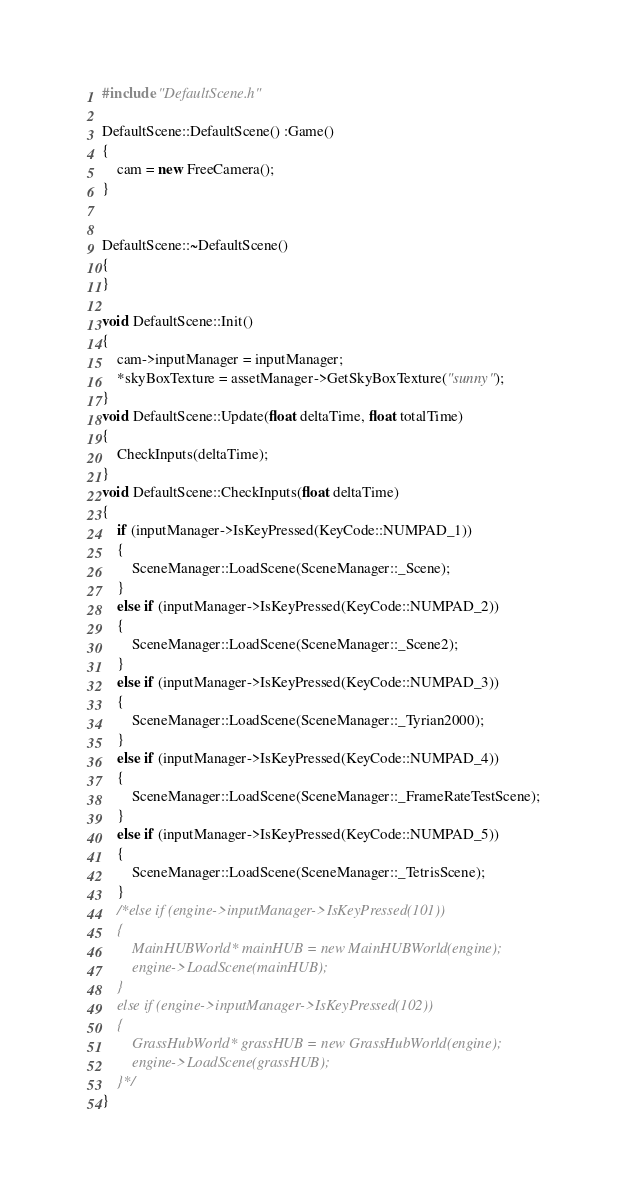Convert code to text. <code><loc_0><loc_0><loc_500><loc_500><_C++_>#include "DefaultScene.h"

DefaultScene::DefaultScene() :Game()
{
	cam = new FreeCamera();
}


DefaultScene::~DefaultScene()
{
}

void DefaultScene::Init()
{
	cam->inputManager = inputManager;
	*skyBoxTexture = assetManager->GetSkyBoxTexture("sunny");
}
void DefaultScene::Update(float deltaTime, float totalTime)
{
	CheckInputs(deltaTime);
}
void DefaultScene::CheckInputs(float deltaTime)
{
	if (inputManager->IsKeyPressed(KeyCode::NUMPAD_1))
	{
		SceneManager::LoadScene(SceneManager::_Scene);
	}
	else if (inputManager->IsKeyPressed(KeyCode::NUMPAD_2))
	{
		SceneManager::LoadScene(SceneManager::_Scene2);
	}
	else if (inputManager->IsKeyPressed(KeyCode::NUMPAD_3))
	{
		SceneManager::LoadScene(SceneManager::_Tyrian2000);
	}
	else if (inputManager->IsKeyPressed(KeyCode::NUMPAD_4))
	{
		SceneManager::LoadScene(SceneManager::_FrameRateTestScene);
	}
	else if (inputManager->IsKeyPressed(KeyCode::NUMPAD_5))
	{
		SceneManager::LoadScene(SceneManager::_TetrisScene);
	}
	/*else if (engine->inputManager->IsKeyPressed(101))
	{
		MainHUBWorld* mainHUB = new MainHUBWorld(engine);
		engine->LoadScene(mainHUB);
	}
	else if (engine->inputManager->IsKeyPressed(102))
	{
		GrassHubWorld* grassHUB = new GrassHubWorld(engine);
		engine->LoadScene(grassHUB);
	}*/
}</code> 